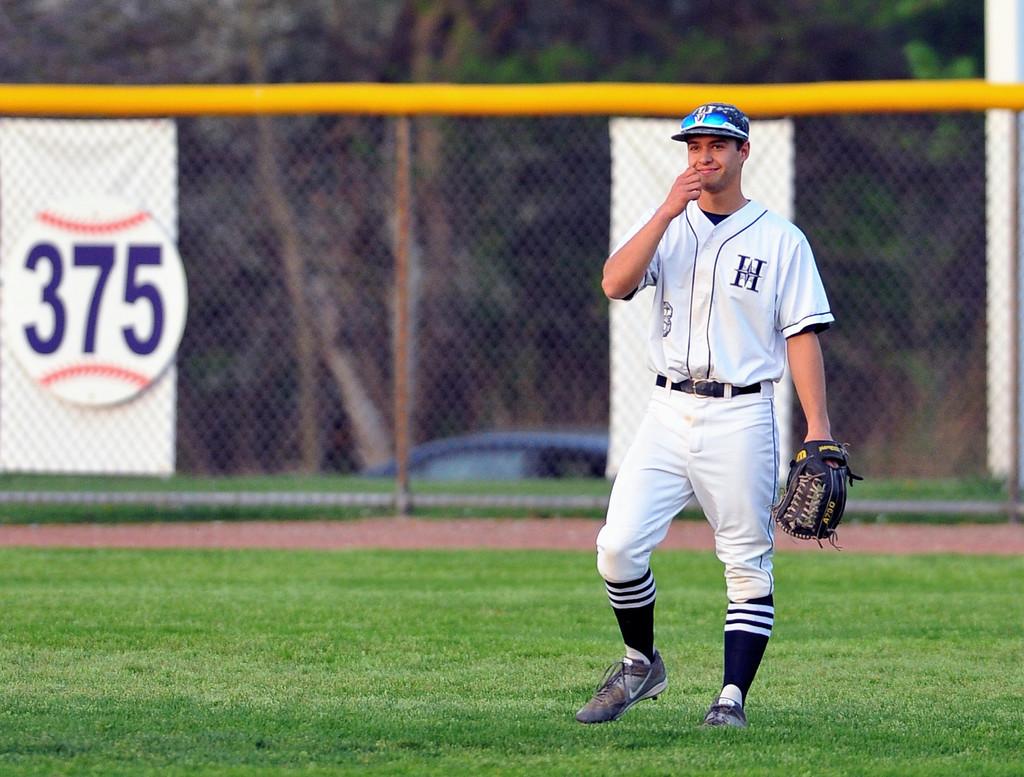What letter is on his shirt?
Your response must be concise. H. 